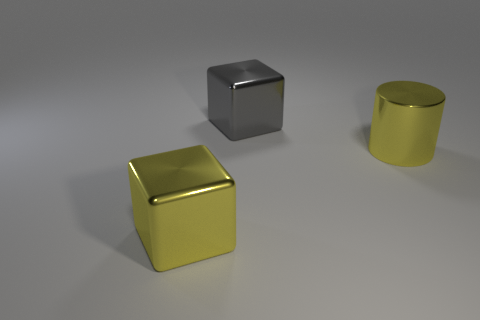Add 2 small balls. How many objects exist? 5 Subtract all cylinders. How many objects are left? 2 Add 1 large gray metal blocks. How many large gray metal blocks exist? 2 Subtract 0 cyan balls. How many objects are left? 3 Subtract all large gray shiny cylinders. Subtract all big gray objects. How many objects are left? 2 Add 2 big shiny objects. How many big shiny objects are left? 5 